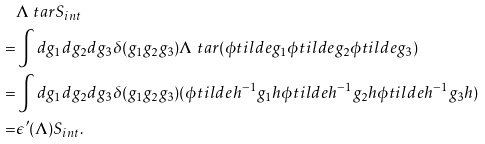<formula> <loc_0><loc_0><loc_500><loc_500>& \Lambda \ t a r S _ { i n t } \\ = & \int d g _ { 1 } d g _ { 2 } d g _ { 3 } \delta ( g _ { 1 } g _ { 2 } g _ { 3 } ) \Lambda \ t a r ( \phi t i l d e { g _ { 1 } } \phi t i l d e { g _ { 2 } } \phi t i l d e { g _ { 3 } } ) \\ = & \int d g _ { 1 } d g _ { 2 } d g _ { 3 } \delta ( g _ { 1 } g _ { 2 } g _ { 3 } ) ( \phi t i l d e { h ^ { - 1 } g _ { 1 } h } \phi t i l d e { h ^ { - 1 } g _ { 2 } h } \phi t i l d e { h ^ { - 1 } g _ { 3 } h } ) \\ = & \epsilon ^ { \prime } ( \Lambda ) S _ { i n t } .</formula> 